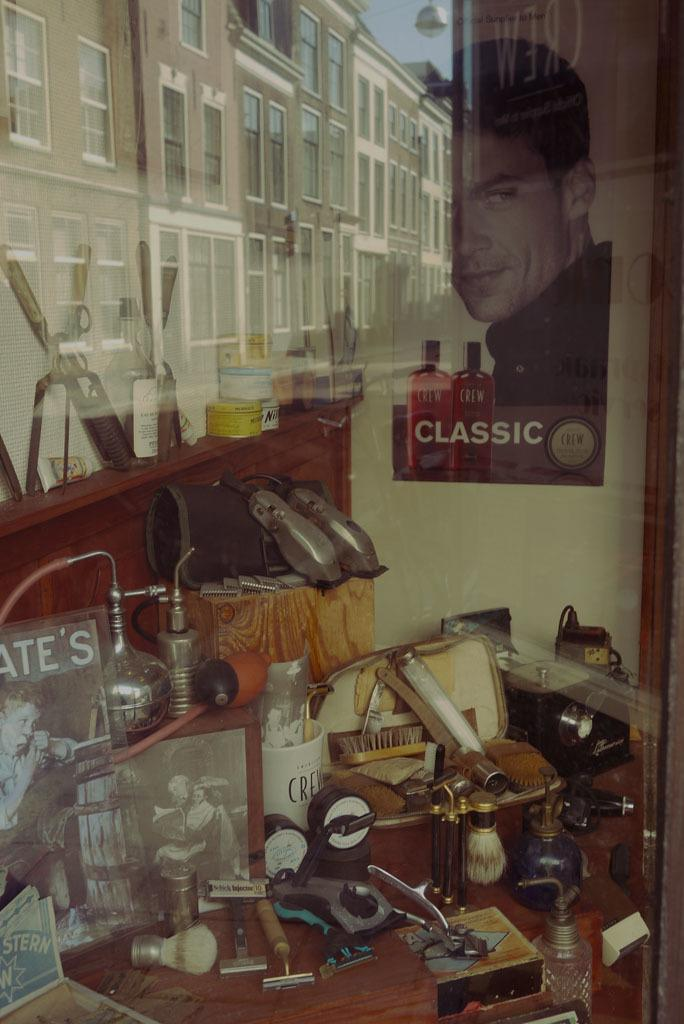<image>
Offer a succinct explanation of the picture presented. A jumbled mess on a desk with a poster that says classic on the wall. 